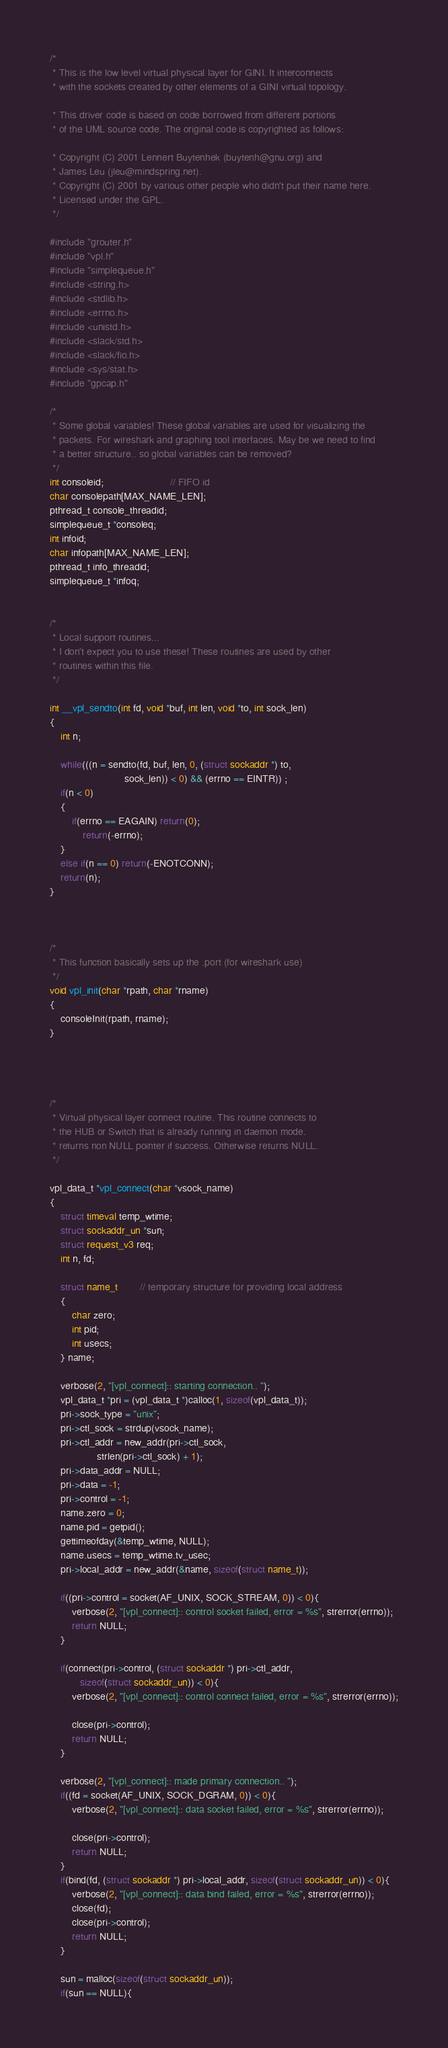<code> <loc_0><loc_0><loc_500><loc_500><_C_>/*
 * This is the low level virtual physical layer for GINI. It interconnects
 * with the sockets created by other elements of a GINI virtual topology.

 * This driver code is based on code borrowed from different portions
 * of the UML source code. The original code is copyrighted as follows:

 * Copyright (C) 2001 Lennert Buytenhek (buytenh@gnu.org) and
 * James Leu (jleu@mindspring.net).
 * Copyright (C) 2001 by various other people who didn't put their name here.
 * Licensed under the GPL.
 */

#include "grouter.h"
#include "vpl.h"
#include "simplequeue.h"
#include <string.h>
#include <stdlib.h>
#include <errno.h>
#include <unistd.h>
#include <slack/std.h>
#include <slack/fio.h>
#include <sys/stat.h>
#include "gpcap.h"

/*
 * Some global variables! These global variables are used for visualizing the
 * packets. For wireshark and graphing tool interfaces. May be we need to find
 * a better structure.. so global variables can be removed?
 */
int consoleid;                        // FIFO id
char consolepath[MAX_NAME_LEN];
pthread_t console_threadid;
simplequeue_t *consoleq;
int infoid;
char infopath[MAX_NAME_LEN];
pthread_t info_threadid;
simplequeue_t *infoq;


/*
 * Local support routines...
 * I don't expect you to use these! These routines are used by other
 * routines within this file.
 */

int __vpl_sendto(int fd, void *buf, int len, void *to, int sock_len)
{
	int n;

	while(((n = sendto(fd, buf, len, 0, (struct sockaddr *) to,
                           sock_len)) < 0) && (errno == EINTR)) ;
	if(n < 0)
	{
		if(errno == EAGAIN) return(0);
        	return(-errno);
	}
	else if(n == 0) return(-ENOTCONN);
	return(n);
}



/*
 * This function basically sets up the .port (for wireshark use)
 */
void vpl_init(char *rpath, char *rname)
{
  	consoleInit(rpath, rname);
}




/*
 * Virtual physical layer connect routine. This routine connects to
 * the HUB or Switch that is already running in daemon mode.
 * returns non NULL pointer if success. Otherwise returns NULL.
 */

vpl_data_t *vpl_connect(char *vsock_name)
{
	struct timeval temp_wtime;
	struct sockaddr_un *sun;
	struct request_v3 req;
	int n, fd;

	struct name_t  		// temporary structure for providing local address
	{
		char zero;
		int pid;
		int usecs;
	} name;

	verbose(2, "[vpl_connect]:: starting connection.. ");
	vpl_data_t *pri = (vpl_data_t *)calloc(1, sizeof(vpl_data_t));
	pri->sock_type = "unix";
	pri->ctl_sock = strdup(vsock_name);
	pri->ctl_addr = new_addr(pri->ctl_sock,
				 strlen(pri->ctl_sock) + 1);
	pri->data_addr = NULL;
	pri->data = -1;
	pri->control = -1;
	name.zero = 0;
	name.pid = getpid();
	gettimeofday(&temp_wtime, NULL);
	name.usecs = temp_wtime.tv_usec;
	pri->local_addr = new_addr(&name, sizeof(struct name_t));

	if((pri->control = socket(AF_UNIX, SOCK_STREAM, 0)) < 0){
		verbose(2, "[vpl_connect]:: control socket failed, error = %s", strerror(errno));
		return NULL;
	}

	if(connect(pri->control, (struct sockaddr *) pri->ctl_addr,
		   sizeof(struct sockaddr_un)) < 0){
		verbose(2, "[vpl_connect]:: control connect failed, error = %s", strerror(errno));

		close(pri->control);
		return NULL;
	}

	verbose(2, "[vpl_connect]:: made primary connection.. ");
	if((fd = socket(AF_UNIX, SOCK_DGRAM, 0)) < 0){
		verbose(2, "[vpl_connect]:: data socket failed, error = %s", strerror(errno));

		close(pri->control);
		return NULL;
	}
	if(bind(fd, (struct sockaddr *) pri->local_addr, sizeof(struct sockaddr_un)) < 0){
		verbose(2, "[vpl_connect]:: data bind failed, error = %s", strerror(errno));
		close(fd);
		close(pri->control);
		return NULL;
	}

	sun = malloc(sizeof(struct sockaddr_un));
	if(sun == NULL){</code> 